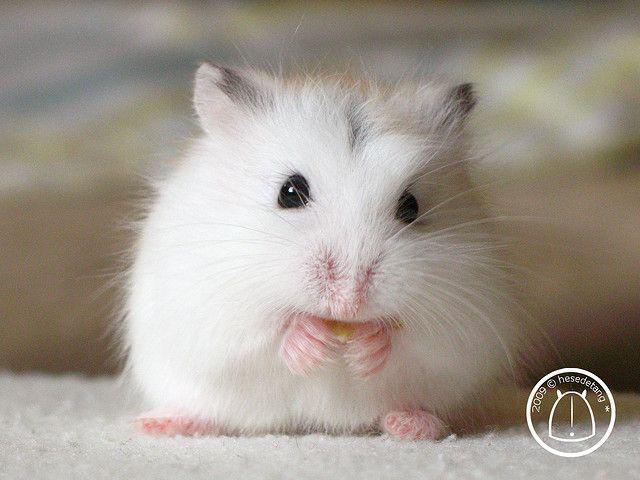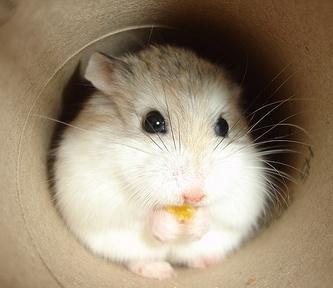The first image is the image on the left, the second image is the image on the right. For the images shown, is this caption "An animal is eating something yellow." true? Answer yes or no. Yes. 